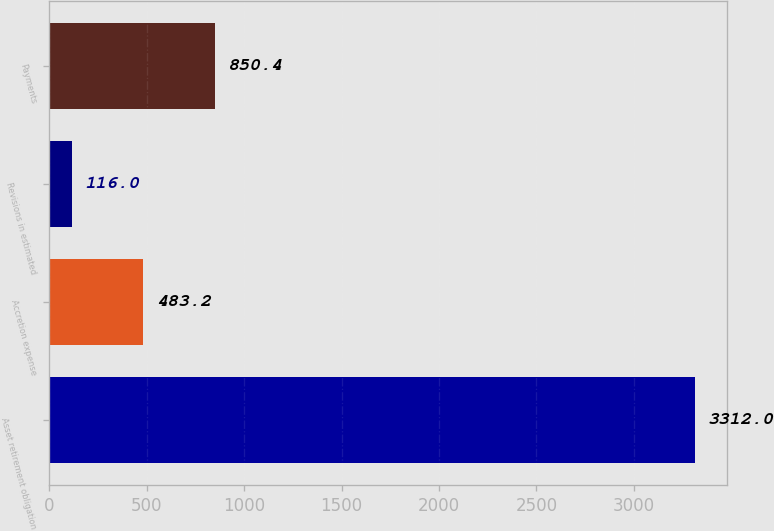Convert chart. <chart><loc_0><loc_0><loc_500><loc_500><bar_chart><fcel>Asset retirement obligation<fcel>Accretion expense<fcel>Revisions in estimated<fcel>Payments<nl><fcel>3312<fcel>483.2<fcel>116<fcel>850.4<nl></chart> 